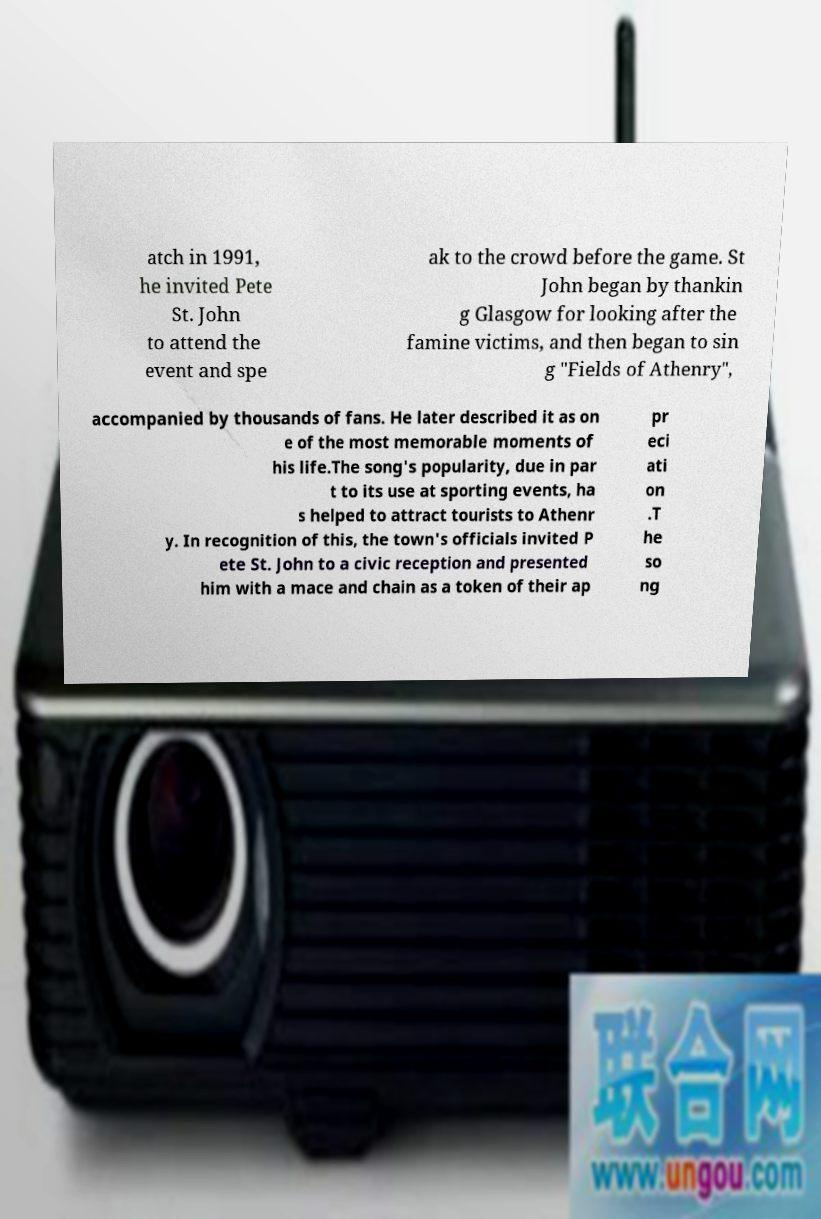Could you extract and type out the text from this image? atch in 1991, he invited Pete St. John to attend the event and spe ak to the crowd before the game. St John began by thankin g Glasgow for looking after the famine victims, and then began to sin g "Fields of Athenry", accompanied by thousands of fans. He later described it as on e of the most memorable moments of his life.The song's popularity, due in par t to its use at sporting events, ha s helped to attract tourists to Athenr y. In recognition of this, the town's officials invited P ete St. John to a civic reception and presented him with a mace and chain as a token of their ap pr eci ati on .T he so ng 